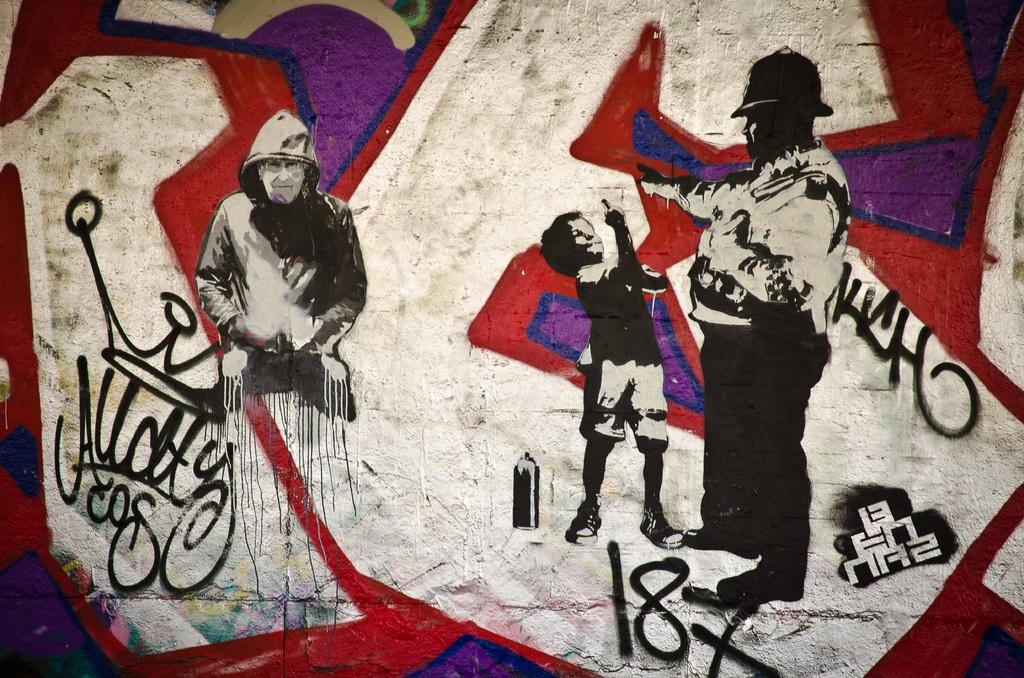What type of artwork is depicted in the image? There are paintings of human beings in the image. Can you describe the surroundings in the image? There are different signs on a wall in the image. What historical event is the stranger discussing in the image? There is no stranger present in the image, and no historical event is being discussed. 